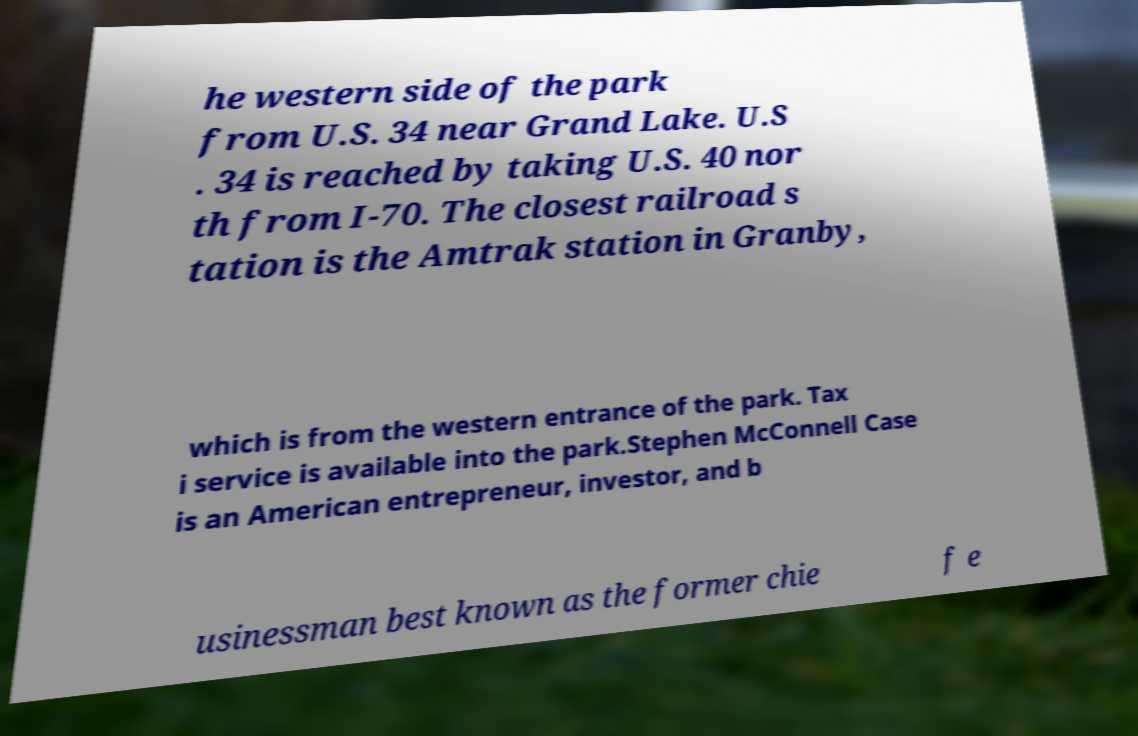Could you assist in decoding the text presented in this image and type it out clearly? he western side of the park from U.S. 34 near Grand Lake. U.S . 34 is reached by taking U.S. 40 nor th from I-70. The closest railroad s tation is the Amtrak station in Granby, which is from the western entrance of the park. Tax i service is available into the park.Stephen McConnell Case is an American entrepreneur, investor, and b usinessman best known as the former chie f e 